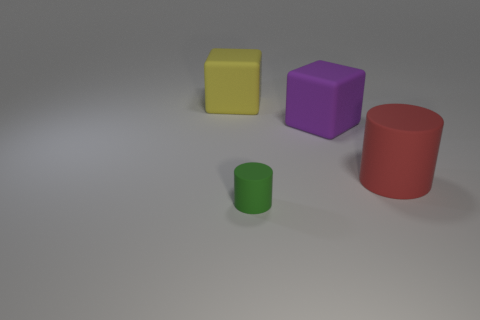Add 4 purple matte objects. How many objects exist? 8 Add 1 red rubber cylinders. How many red rubber cylinders are left? 2 Add 3 gray rubber blocks. How many gray rubber blocks exist? 3 Subtract 0 purple cylinders. How many objects are left? 4 Subtract all small cyan metallic things. Subtract all rubber cubes. How many objects are left? 2 